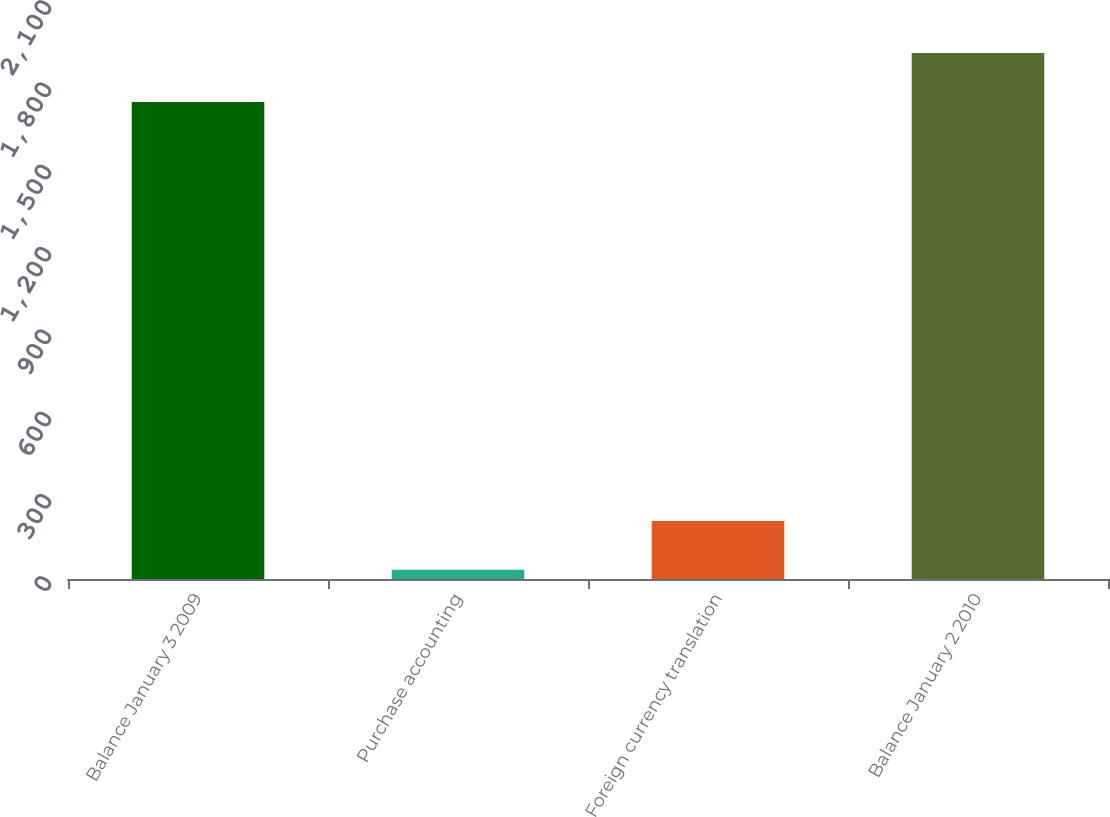Convert chart to OTSL. <chart><loc_0><loc_0><loc_500><loc_500><bar_chart><fcel>Balance January 3 2009<fcel>Purchase accounting<fcel>Foreign currency translation<fcel>Balance January 2 2010<nl><fcel>1739.2<fcel>33.3<fcel>211.81<fcel>1917.71<nl></chart> 